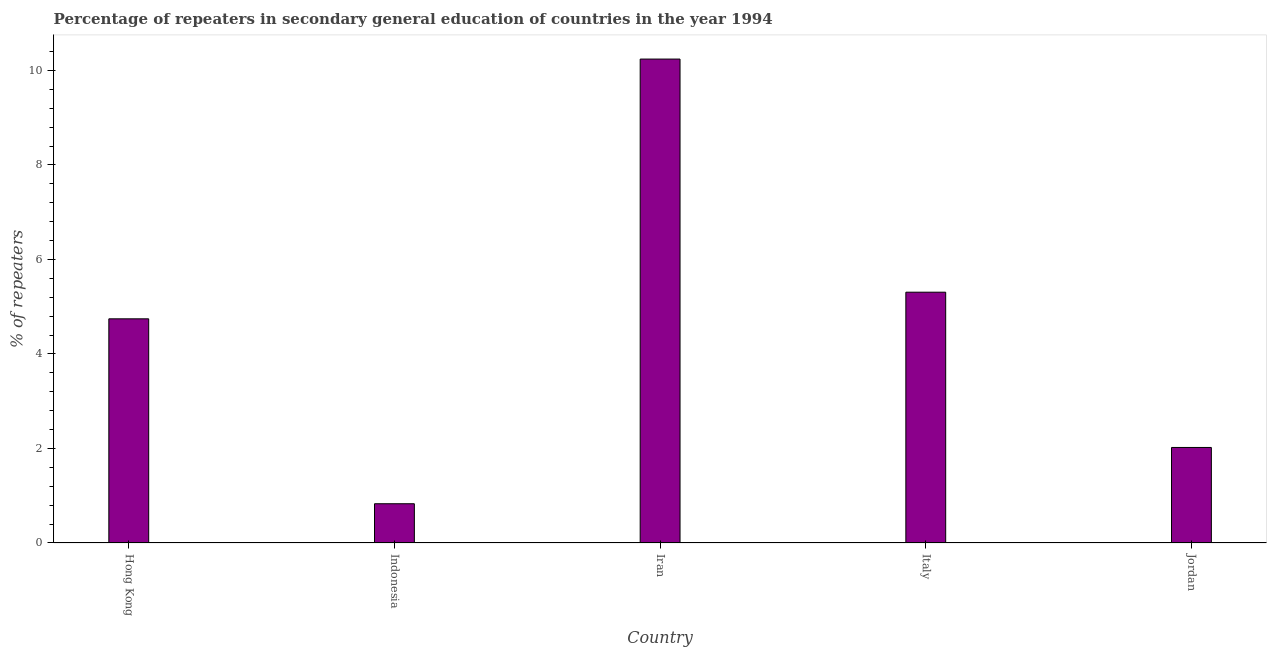Does the graph contain any zero values?
Offer a very short reply. No. Does the graph contain grids?
Your answer should be compact. No. What is the title of the graph?
Keep it short and to the point. Percentage of repeaters in secondary general education of countries in the year 1994. What is the label or title of the Y-axis?
Give a very brief answer. % of repeaters. What is the percentage of repeaters in Hong Kong?
Your answer should be very brief. 4.74. Across all countries, what is the maximum percentage of repeaters?
Offer a terse response. 10.24. Across all countries, what is the minimum percentage of repeaters?
Give a very brief answer. 0.83. In which country was the percentage of repeaters maximum?
Ensure brevity in your answer.  Iran. In which country was the percentage of repeaters minimum?
Provide a succinct answer. Indonesia. What is the sum of the percentage of repeaters?
Your answer should be compact. 23.14. What is the difference between the percentage of repeaters in Italy and Jordan?
Offer a terse response. 3.29. What is the average percentage of repeaters per country?
Ensure brevity in your answer.  4.63. What is the median percentage of repeaters?
Keep it short and to the point. 4.74. In how many countries, is the percentage of repeaters greater than 7.6 %?
Your answer should be very brief. 1. What is the ratio of the percentage of repeaters in Hong Kong to that in Iran?
Your answer should be very brief. 0.46. Is the percentage of repeaters in Italy less than that in Jordan?
Provide a succinct answer. No. What is the difference between the highest and the second highest percentage of repeaters?
Your response must be concise. 4.93. Is the sum of the percentage of repeaters in Hong Kong and Italy greater than the maximum percentage of repeaters across all countries?
Ensure brevity in your answer.  No. What is the difference between the highest and the lowest percentage of repeaters?
Keep it short and to the point. 9.41. In how many countries, is the percentage of repeaters greater than the average percentage of repeaters taken over all countries?
Your answer should be very brief. 3. Are all the bars in the graph horizontal?
Your response must be concise. No. How many countries are there in the graph?
Make the answer very short. 5. Are the values on the major ticks of Y-axis written in scientific E-notation?
Your answer should be very brief. No. What is the % of repeaters of Hong Kong?
Offer a terse response. 4.74. What is the % of repeaters of Indonesia?
Provide a succinct answer. 0.83. What is the % of repeaters of Iran?
Make the answer very short. 10.24. What is the % of repeaters in Italy?
Ensure brevity in your answer.  5.31. What is the % of repeaters of Jordan?
Your answer should be very brief. 2.02. What is the difference between the % of repeaters in Hong Kong and Indonesia?
Give a very brief answer. 3.91. What is the difference between the % of repeaters in Hong Kong and Iran?
Keep it short and to the point. -5.5. What is the difference between the % of repeaters in Hong Kong and Italy?
Give a very brief answer. -0.56. What is the difference between the % of repeaters in Hong Kong and Jordan?
Provide a succinct answer. 2.72. What is the difference between the % of repeaters in Indonesia and Iran?
Ensure brevity in your answer.  -9.41. What is the difference between the % of repeaters in Indonesia and Italy?
Your response must be concise. -4.48. What is the difference between the % of repeaters in Indonesia and Jordan?
Ensure brevity in your answer.  -1.19. What is the difference between the % of repeaters in Iran and Italy?
Your answer should be compact. 4.93. What is the difference between the % of repeaters in Iran and Jordan?
Your answer should be compact. 8.22. What is the difference between the % of repeaters in Italy and Jordan?
Ensure brevity in your answer.  3.29. What is the ratio of the % of repeaters in Hong Kong to that in Indonesia?
Keep it short and to the point. 5.71. What is the ratio of the % of repeaters in Hong Kong to that in Iran?
Your answer should be very brief. 0.46. What is the ratio of the % of repeaters in Hong Kong to that in Italy?
Your answer should be compact. 0.89. What is the ratio of the % of repeaters in Hong Kong to that in Jordan?
Offer a very short reply. 2.35. What is the ratio of the % of repeaters in Indonesia to that in Iran?
Offer a terse response. 0.08. What is the ratio of the % of repeaters in Indonesia to that in Italy?
Your answer should be very brief. 0.16. What is the ratio of the % of repeaters in Indonesia to that in Jordan?
Your response must be concise. 0.41. What is the ratio of the % of repeaters in Iran to that in Italy?
Provide a short and direct response. 1.93. What is the ratio of the % of repeaters in Iran to that in Jordan?
Make the answer very short. 5.07. What is the ratio of the % of repeaters in Italy to that in Jordan?
Make the answer very short. 2.62. 